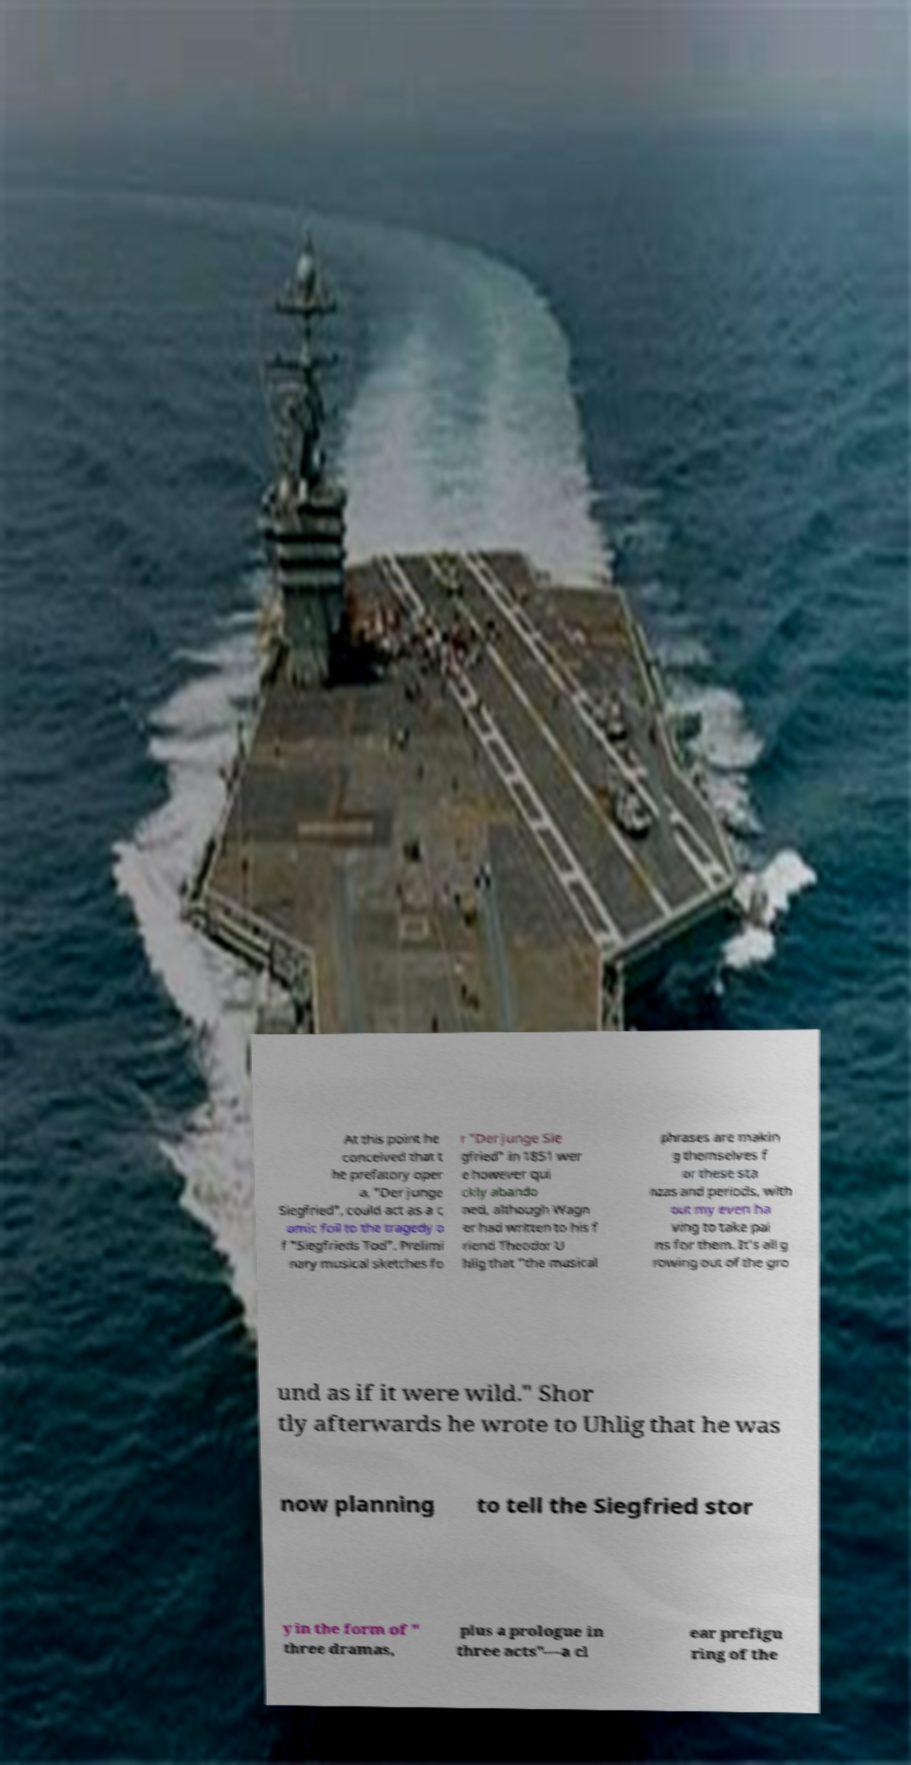Can you read and provide the text displayed in the image?This photo seems to have some interesting text. Can you extract and type it out for me? At this point he conceived that t he prefatory oper a, "Der junge Siegfried", could act as a c omic foil to the tragedy o f "Siegfrieds Tod". Prelimi nary musical sketches fo r "Der junge Sie gfried" in 1851 wer e however qui ckly abando ned, although Wagn er had written to his f riend Theodor U hlig that "the musical phrases are makin g themselves f or these sta nzas and periods, with out my even ha ving to take pai ns for them. It's all g rowing out of the gro und as if it were wild." Shor tly afterwards he wrote to Uhlig that he was now planning to tell the Siegfried stor y in the form of " three dramas, plus a prologue in three acts"—a cl ear prefigu ring of the 